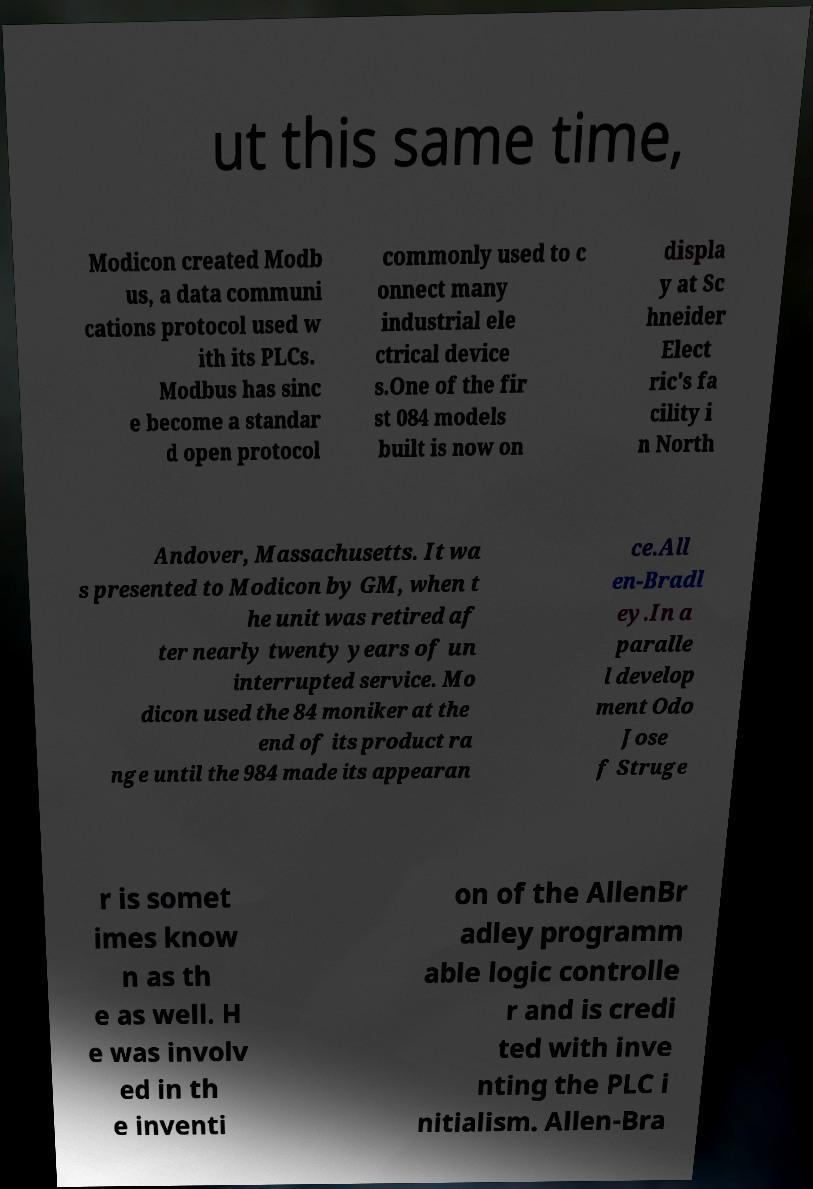Could you extract and type out the text from this image? ut this same time, Modicon created Modb us, a data communi cations protocol used w ith its PLCs. Modbus has sinc e become a standar d open protocol commonly used to c onnect many industrial ele ctrical device s.One of the fir st 084 models built is now on displa y at Sc hneider Elect ric's fa cility i n North Andover, Massachusetts. It wa s presented to Modicon by GM, when t he unit was retired af ter nearly twenty years of un interrupted service. Mo dicon used the 84 moniker at the end of its product ra nge until the 984 made its appearan ce.All en-Bradl ey.In a paralle l develop ment Odo Jose f Struge r is somet imes know n as th e as well. H e was involv ed in th e inventi on of the AllenBr adley programm able logic controlle r and is credi ted with inve nting the PLC i nitialism. Allen-Bra 